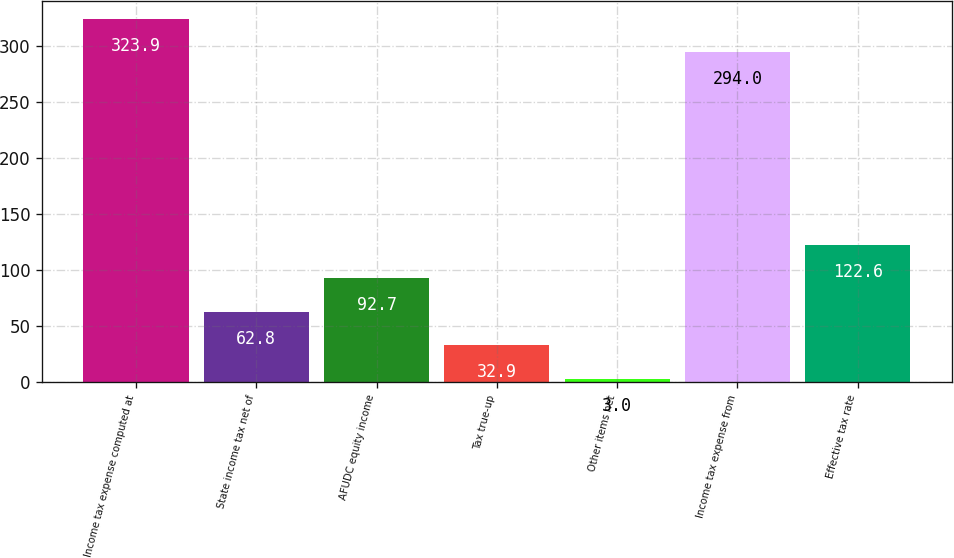<chart> <loc_0><loc_0><loc_500><loc_500><bar_chart><fcel>Income tax expense computed at<fcel>State income tax net of<fcel>AFUDC equity income<fcel>Tax true-up<fcel>Other items net<fcel>Income tax expense from<fcel>Effective tax rate<nl><fcel>323.9<fcel>62.8<fcel>92.7<fcel>32.9<fcel>3<fcel>294<fcel>122.6<nl></chart> 